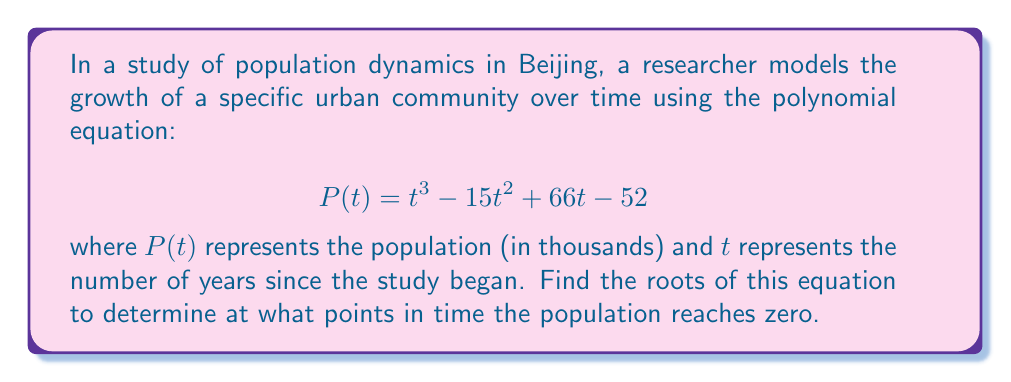Could you help me with this problem? To find the roots of the polynomial equation, we need to solve:

$$t^3 - 15t^2 + 66t - 52 = 0$$

Let's approach this step-by-step:

1) First, we can try to factor out a common factor. In this case, there is no common factor.

2) Next, we can try to guess one root. By inspection or trial and error, we can find that $t = 1$ is a root.

3) Using polynomial long division or synthetic division, we can divide the polynomial by $(t - 1)$:

   $t^3 - 15t^2 + 66t - 52 = (t - 1)(t^2 - 14t + 52)$

4) Now we have reduced our problem to solving:

   $(t - 1)(t^2 - 14t + 52) = 0$

5) By the zero product property, either $t - 1 = 0$ or $t^2 - 14t + 52 = 0$

6) We already know $t = 1$ is a solution. For the quadratic equation $t^2 - 14t + 52 = 0$, we can use the quadratic formula:

   $$t = \frac{-b \pm \sqrt{b^2 - 4ac}}{2a}$$

   where $a = 1$, $b = -14$, and $c = 52$

7) Substituting these values:

   $$t = \frac{14 \pm \sqrt{196 - 208}}{2} = \frac{14 \pm \sqrt{-12}}{2}$$

8) Since the discriminant is negative, there are no real roots for this quadratic equation.

Therefore, the only real root of the original equation is $t = 1$.
Answer: $t = 1$ 